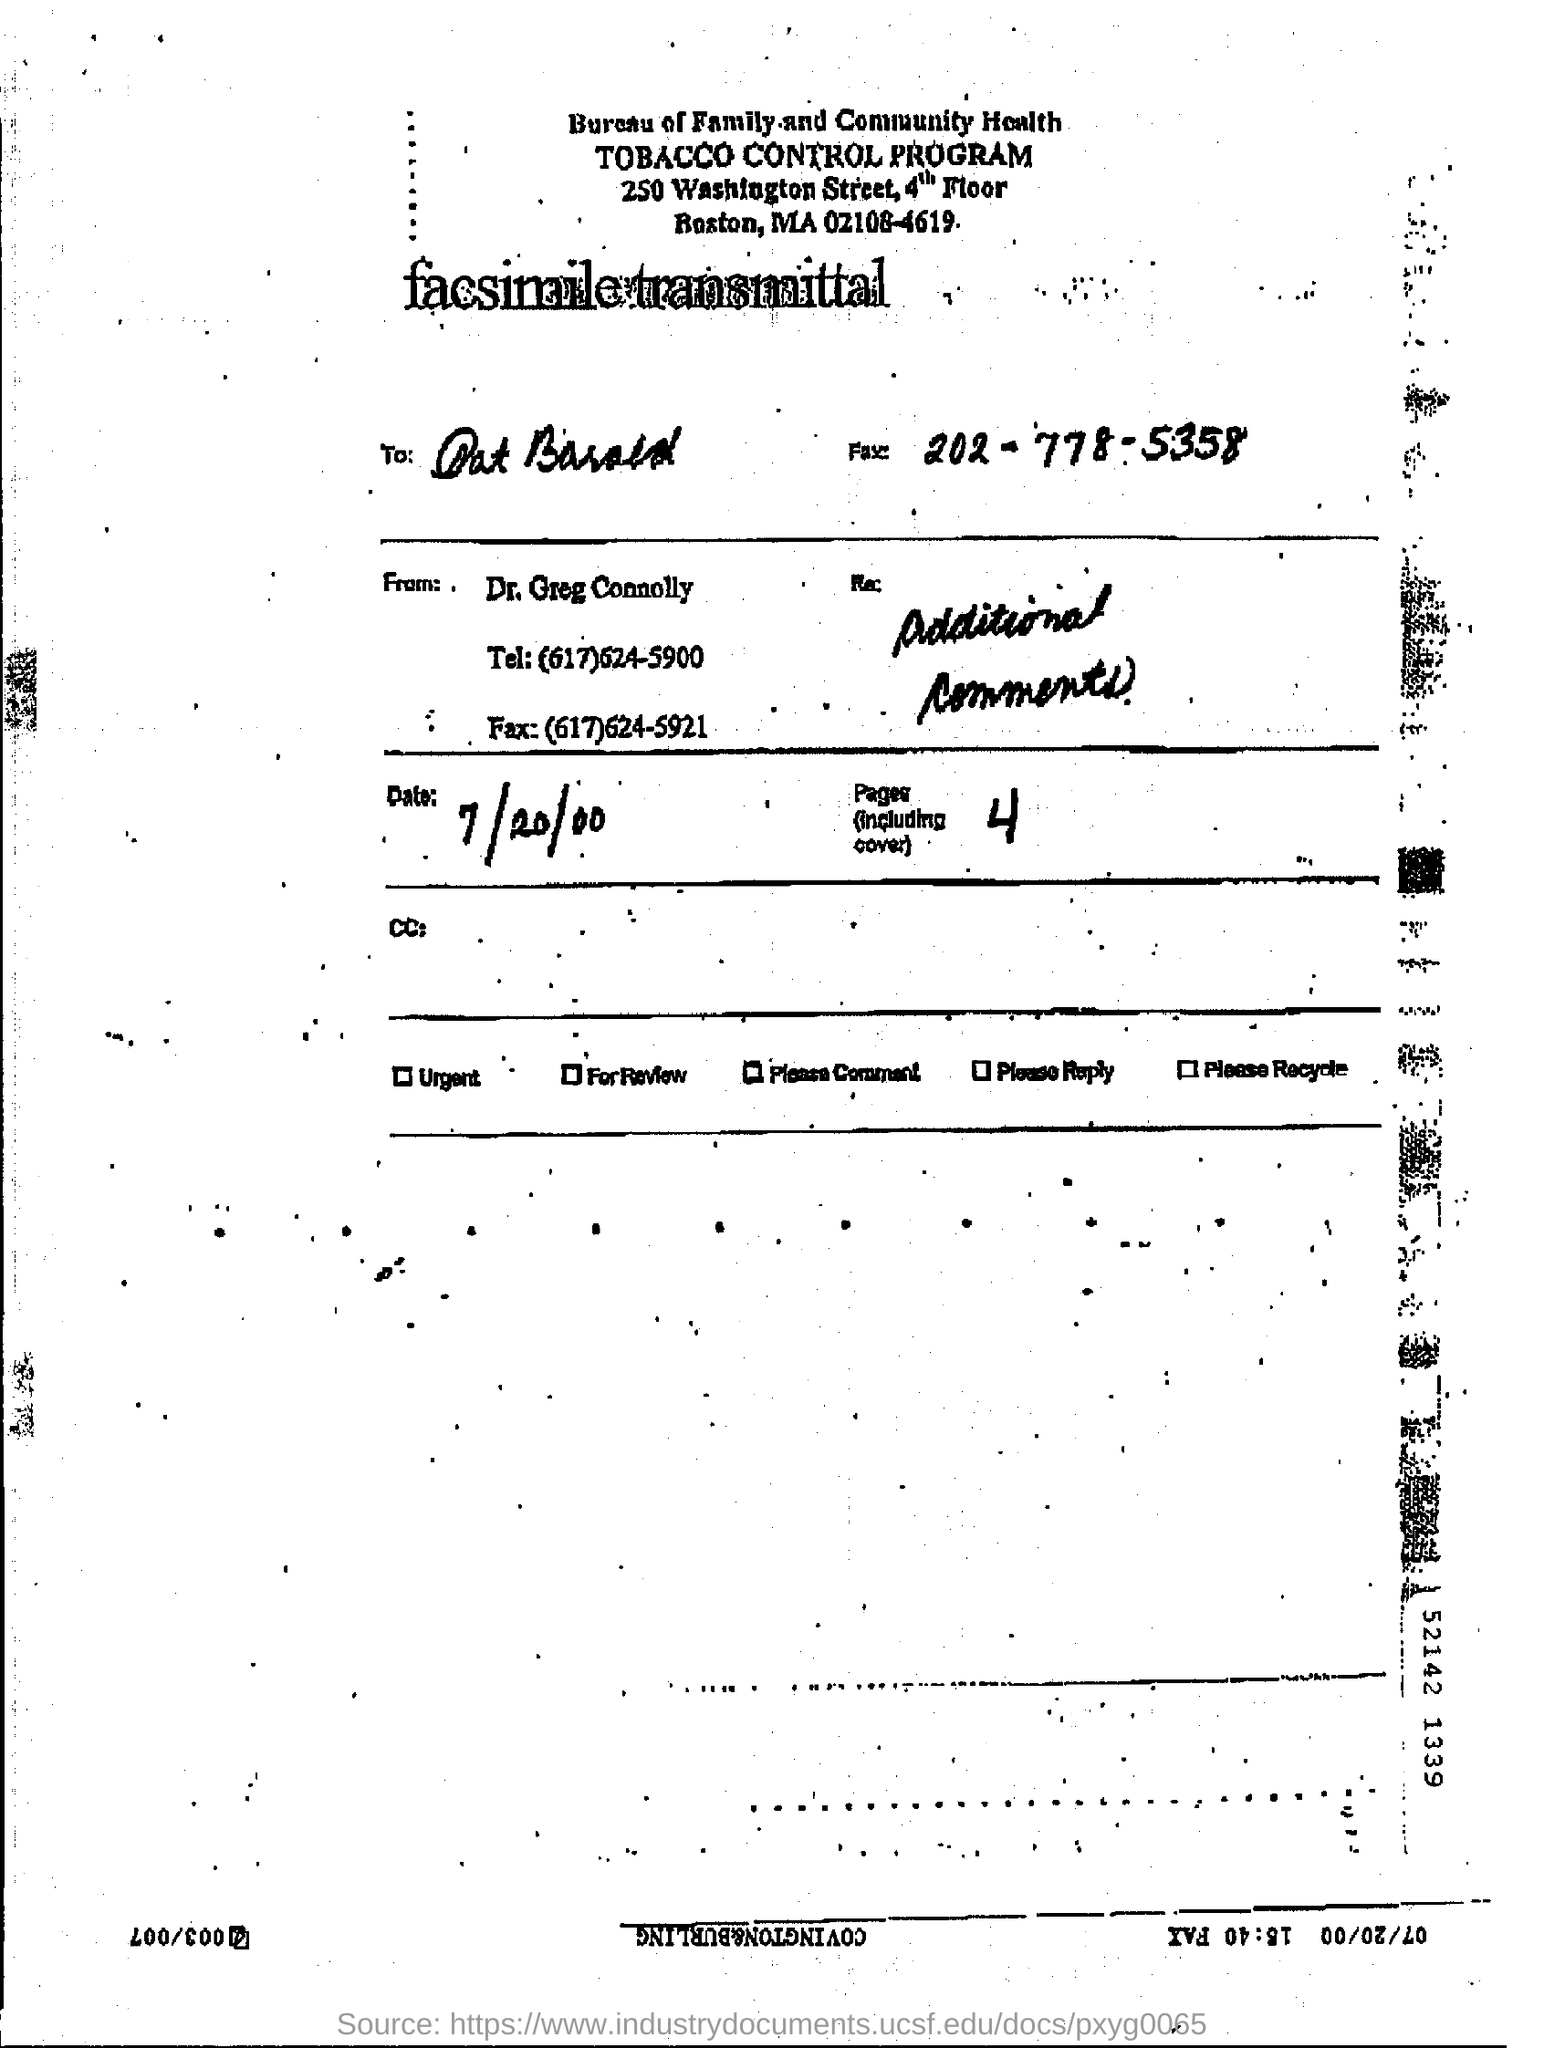What is the name of the program ?
Give a very brief answer. Tobacco control program. What is the fax number given ?
Ensure brevity in your answer.  202-778-5358. How many pages are there (including cover) ?
Make the answer very short. 4. What is the date mentioned in the page ?
Your response must be concise. 7/20/00. 